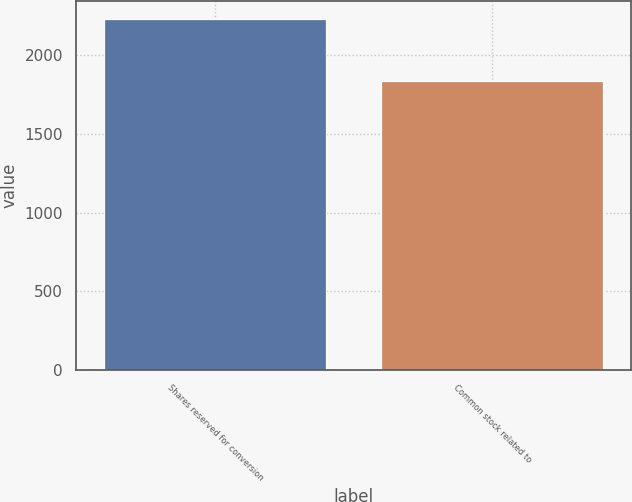Convert chart to OTSL. <chart><loc_0><loc_0><loc_500><loc_500><bar_chart><fcel>Shares reserved for conversion<fcel>Common stock related to<nl><fcel>2232<fcel>1835<nl></chart> 